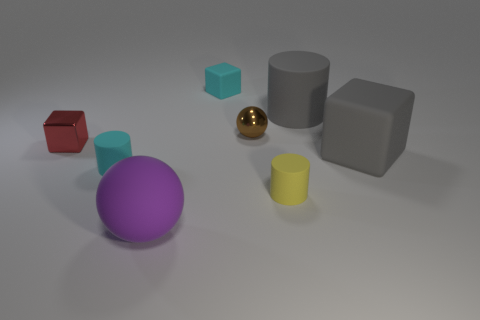Could the scene be part of a computer graphics project? Absolutely, the objects in the image display characteristics indicative of 3D modeling, such as perfectly smooth surfaces and uniform colors, which suggest they may have been created and rendered using computer graphics software. 